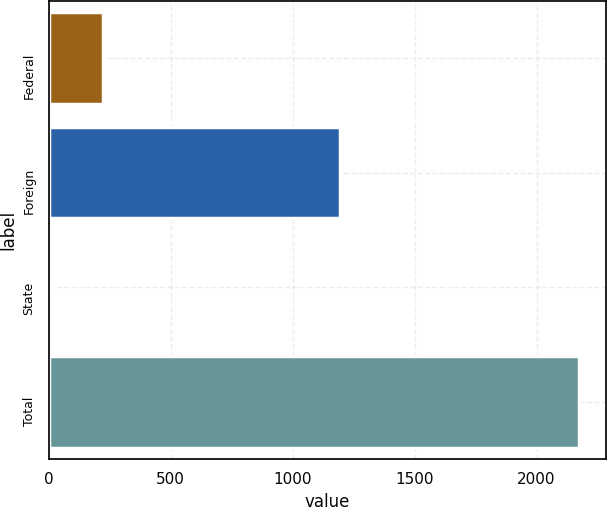Convert chart to OTSL. <chart><loc_0><loc_0><loc_500><loc_500><bar_chart><fcel>Federal<fcel>Foreign<fcel>State<fcel>Total<nl><fcel>223.7<fcel>1193<fcel>7<fcel>2174<nl></chart> 